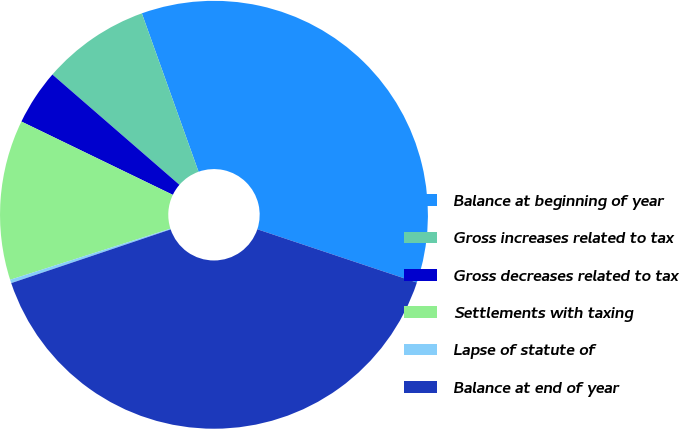Convert chart to OTSL. <chart><loc_0><loc_0><loc_500><loc_500><pie_chart><fcel>Balance at beginning of year<fcel>Gross increases related to tax<fcel>Gross decreases related to tax<fcel>Settlements with taxing<fcel>Lapse of statute of<fcel>Balance at end of year<nl><fcel>35.6%<fcel>8.15%<fcel>4.2%<fcel>12.09%<fcel>0.26%<fcel>39.69%<nl></chart> 